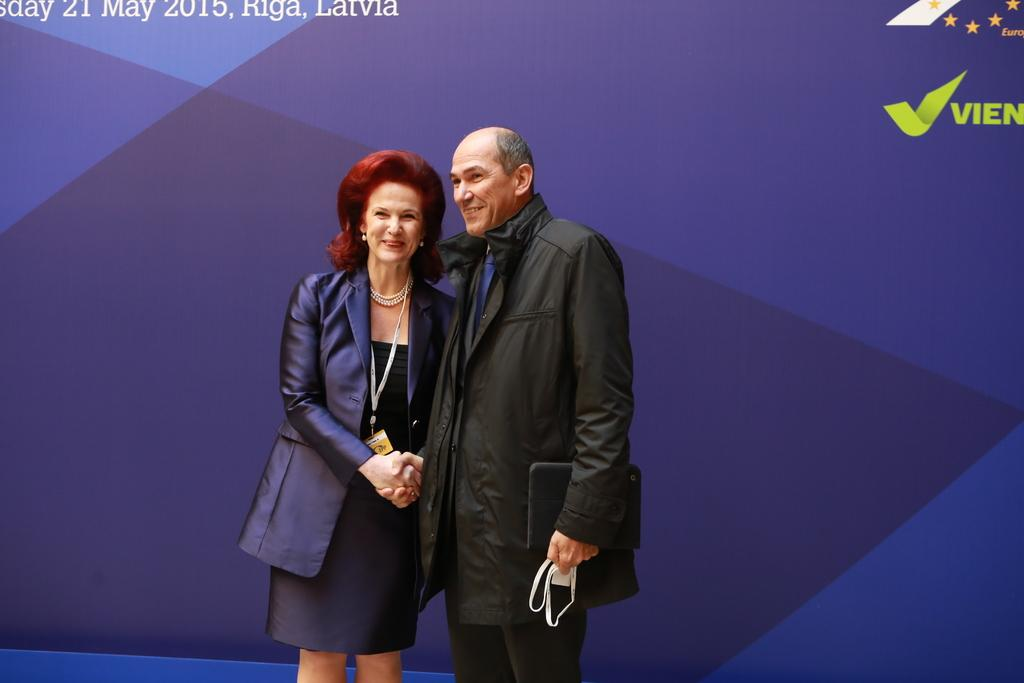How many people are in the image? There are two persons in the image. What are the two persons doing? The two persons are standing and shaking hands. What expression do the persons have on their faces? Both persons have a smile on their face. Can you describe the object held by one of the persons? One of the persons is holding an object in his hand, but the specific details of the object are not mentioned in the facts. What type of beetle can be seen crawling on the person's hand in the image? There is no beetle present in the image; the facts only mention that one of the persons is holding an object in his hand. How does the bean affect the interaction between the two persons in the image? There is no bean mentioned in the image, so it cannot have any effect on the interaction between the two persons. 